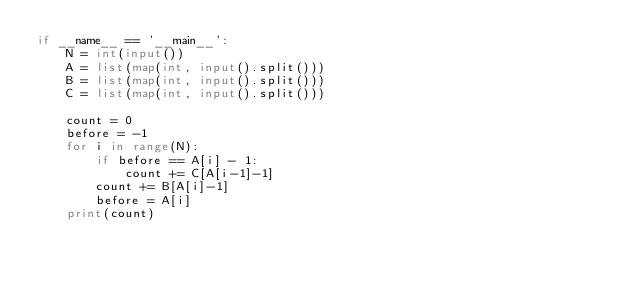<code> <loc_0><loc_0><loc_500><loc_500><_Python_>if __name__ == '__main__':
    N = int(input())    
    A = list(map(int, input().split()))
    B = list(map(int, input().split()))
    C = list(map(int, input().split()))

    count = 0
    before = -1
    for i in range(N):
        if before == A[i] - 1:
            count += C[A[i-1]-1]
        count += B[A[i]-1]
        before = A[i]
    print(count)</code> 